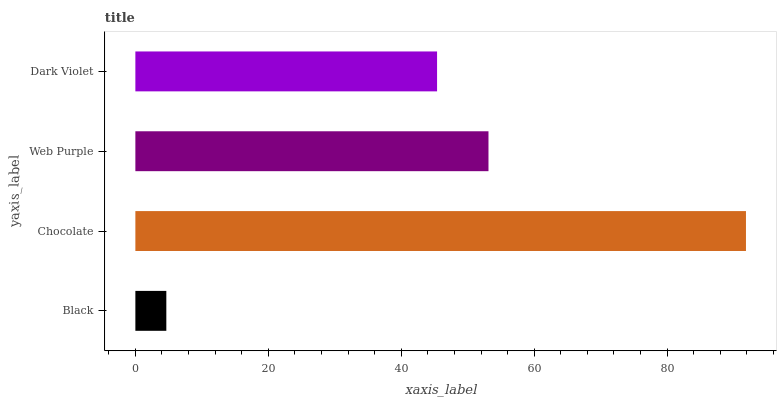Is Black the minimum?
Answer yes or no. Yes. Is Chocolate the maximum?
Answer yes or no. Yes. Is Web Purple the minimum?
Answer yes or no. No. Is Web Purple the maximum?
Answer yes or no. No. Is Chocolate greater than Web Purple?
Answer yes or no. Yes. Is Web Purple less than Chocolate?
Answer yes or no. Yes. Is Web Purple greater than Chocolate?
Answer yes or no. No. Is Chocolate less than Web Purple?
Answer yes or no. No. Is Web Purple the high median?
Answer yes or no. Yes. Is Dark Violet the low median?
Answer yes or no. Yes. Is Black the high median?
Answer yes or no. No. Is Black the low median?
Answer yes or no. No. 